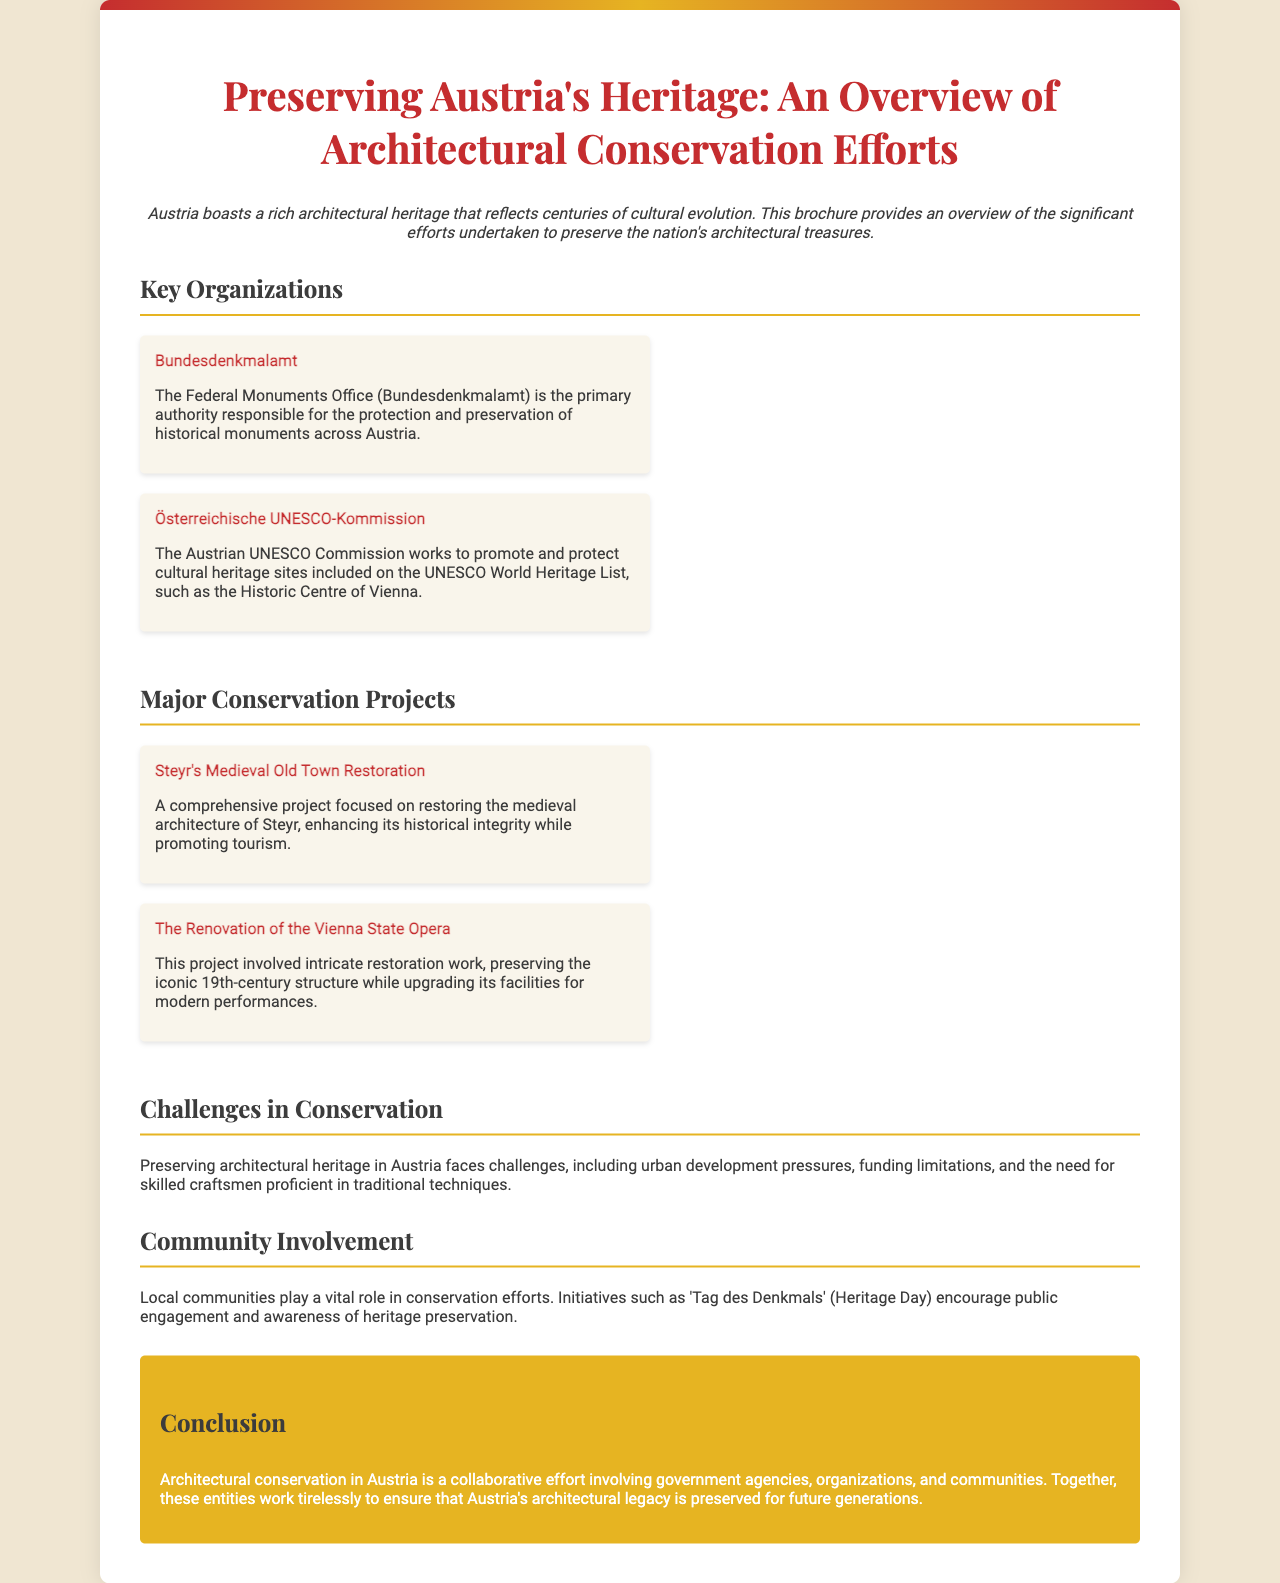What is the primary authority for historical monument protection in Austria? The document states that the Federal Monuments Office (Bundesdenkmalamt) is the primary authority responsible for the protection and preservation of historical monuments across Austria.
Answer: Bundesdenkmalamt Which UNESCO World Heritage site is mentioned in the brochure? The Austrian UNESCO Commission promotes and protects cultural heritage sites, specifically mentioning the Historic Centre of Vienna as a UNESCO World Heritage site.
Answer: Historic Centre of Vienna What is one major conservation project listed in the document? The document provides information on the Steyr's Medieval Old Town Restoration, which is one of the major conservation projects focused on restoring medieval architecture.
Answer: Steyr's Medieval Old Town Restoration What challenge in conservation is highlighted in the brochure? The document mentions urban development pressures as one of the challenges faced in preserving architectural heritage in Austria.
Answer: Urban development pressures What date is associated with public engagement initiatives in heritage preservation? The document refers to 'Tag des Denkmals' (Heritage Day) as an initiative promoting public engagement and awareness of heritage preservation.
Answer: Tag des Denkmals 